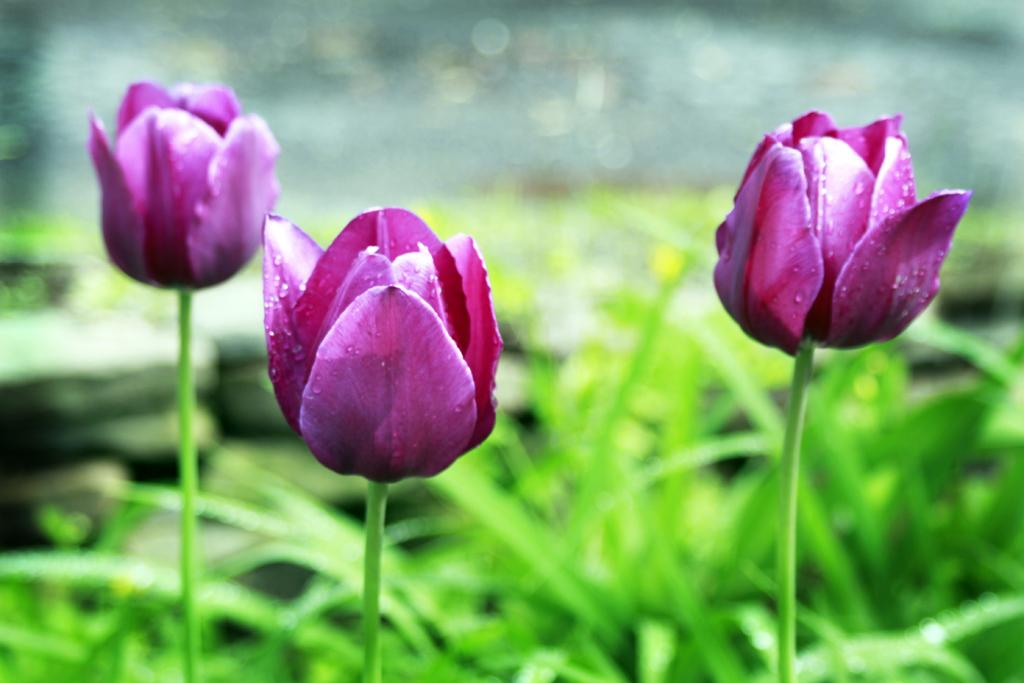What type of flower is in the image? The flower in the image is a tulip. What color is the tulip? The tulip is purple in color. Can you describe any additional details about the tulip? Yes, there are droplets of water on the tulip. What can be said about the background of the image? The background of the image is blurred and cannot be clearly seen. What type of sheet is covering the root of the tulip in the image? There is no sheet covering the root of the tulip in the image; the root is not visible. What is the tulip using to carry water in the image? The tulip is not using a pail or any other container to carry water in the image; it is simply depicted with droplets of water on its petals. 